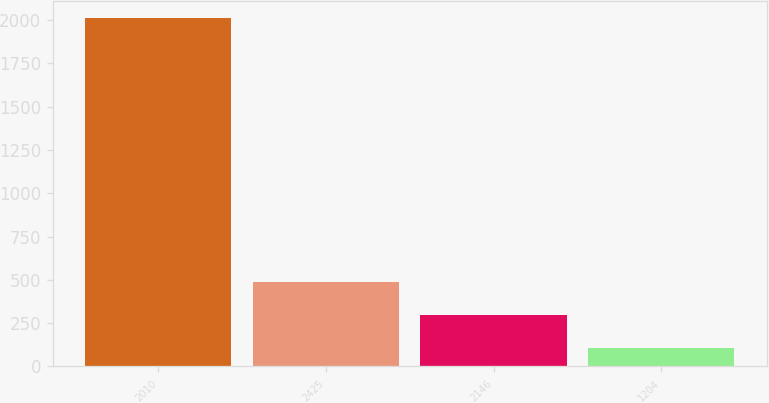Convert chart. <chart><loc_0><loc_0><loc_500><loc_500><bar_chart><fcel>2010<fcel>2425<fcel>2146<fcel>1204<nl><fcel>2009<fcel>488.36<fcel>298.28<fcel>108.2<nl></chart> 